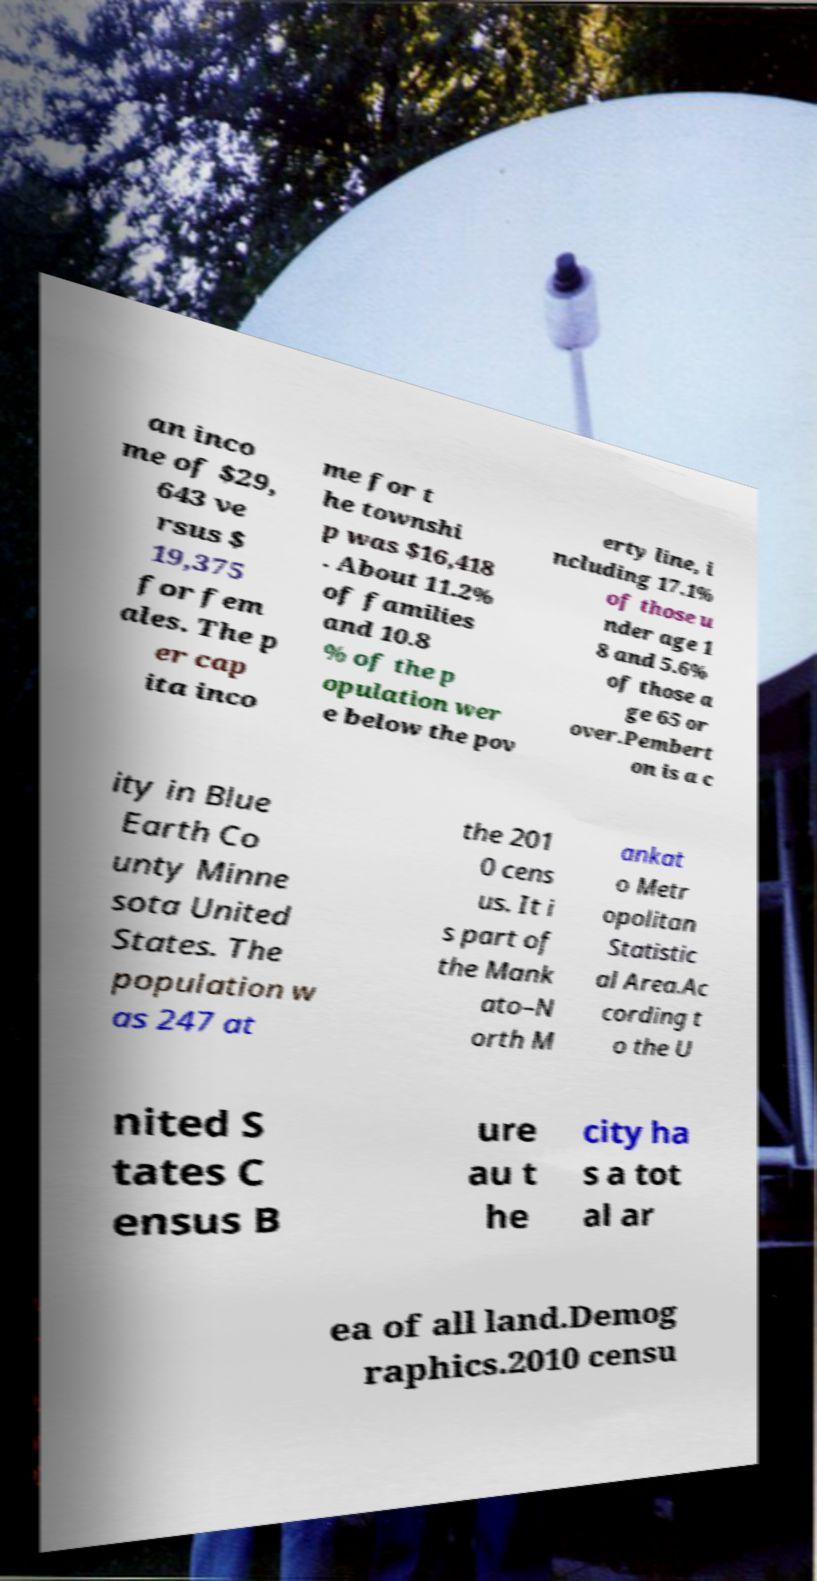For documentation purposes, I need the text within this image transcribed. Could you provide that? an inco me of $29, 643 ve rsus $ 19,375 for fem ales. The p er cap ita inco me for t he townshi p was $16,418 . About 11.2% of families and 10.8 % of the p opulation wer e below the pov erty line, i ncluding 17.1% of those u nder age 1 8 and 5.6% of those a ge 65 or over.Pembert on is a c ity in Blue Earth Co unty Minne sota United States. The population w as 247 at the 201 0 cens us. It i s part of the Mank ato–N orth M ankat o Metr opolitan Statistic al Area.Ac cording t o the U nited S tates C ensus B ure au t he city ha s a tot al ar ea of all land.Demog raphics.2010 censu 